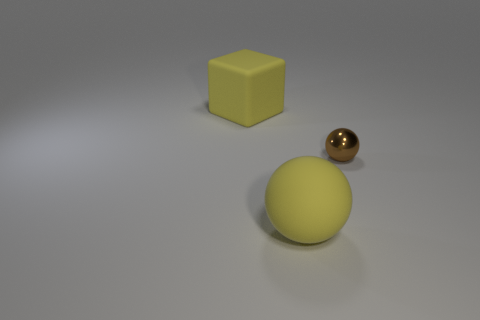Is the number of large yellow blocks right of the big block less than the number of big yellow rubber spheres?
Give a very brief answer. Yes. Do the large block and the tiny brown ball have the same material?
Offer a very short reply. No. What number of things are shiny spheres or tiny yellow metal cubes?
Make the answer very short. 1. How many yellow objects have the same material as the big ball?
Your response must be concise. 1. What is the size of the yellow rubber thing that is the same shape as the tiny brown object?
Offer a terse response. Large. There is a tiny brown metallic ball; are there any yellow things left of it?
Your answer should be compact. Yes. What is the material of the large yellow cube?
Keep it short and to the point. Rubber. There is a matte thing that is behind the tiny sphere; is it the same color as the tiny shiny object?
Your response must be concise. No. Is there any other thing that is the same shape as the metal thing?
Give a very brief answer. Yes. What is the color of the other thing that is the same shape as the tiny brown metal thing?
Ensure brevity in your answer.  Yellow. 